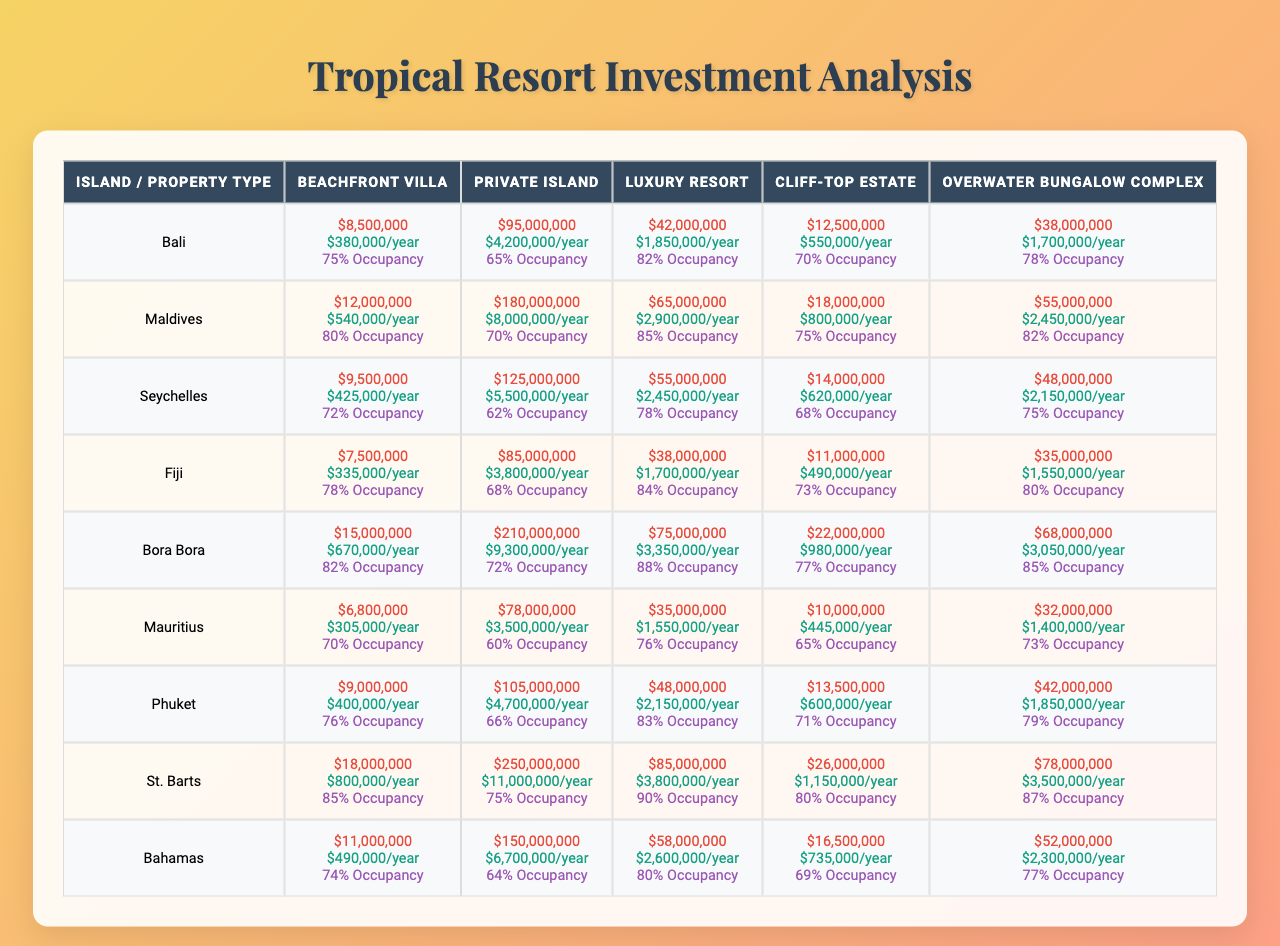What is the acquisition cost of a Beachfront Villa in Bora Bora? According to the table, the acquisition cost for a Beachfront Villa in Bora Bora is $15,000,000.
Answer: $15,000,000 Which island has the highest acquisition cost for a Private Island? By examining the table, the Maldives has the highest acquisition cost for a Private Island at $180,000,000.
Answer: Maldives What is the average occupancy rate for Luxury Resorts across all islands? Summing the average occupancy rates for Luxury Resorts (0.82 + 0.85 + 0.78 + 0.84 + 0.88 + 0.76 + 0.83 + 0.90 + 0.80) gives 7.34, and dividing by the number of islands (9) results in an average of 0.8156, or approximately 81.56%.
Answer: 81.56% Is the yearly maintenance cost for a Cliff-top Estate in Bali higher than $1,000,000? The yearly maintenance cost for a Cliff-top Estate in Bali is $550,000, which is less than $1,000,000.
Answer: No What is the total acquisition cost for Luxury Resorts from all the islands? The acquisition costs for Luxury Resorts from the islands are ($42,000,000 + $65,000,000 + $55,000,000 + $38,000,000 + $75,000,000 + $35,000,000 + $48,000,000 + $85,000,000 + $58,000,000), totaling $488,000,000.
Answer: $488,000,000 Which island has the lowest yearly maintenance cost for an Overwater Bungalow Complex? Referring to the table, Mauritius has the lowest yearly maintenance cost for an Overwater Bungalow Complex at $1,400,000.
Answer: Mauritius If I were to acquire a Luxury Resort in both Seychelles and Maldives, what would be the total acquisition cost? The acquisition costs for Luxury Resorts in Seychelles and Maldives are $55,000,000 and $65,000,000 respectively. Adding these together ($55,000,000 + $65,000,000) results in a total acquisition cost of $120,000,000.
Answer: $120,000,000 Is the average occupancy rate for St. Barts’ beachfront villas lower than 75%? The average occupancy rate for St. Barts’ Beachfront Villas is 85%, which is higher than 75%.
Answer: No How does the yearly maintenance cost for a Private Island in Fiji compare to that in Maui? The yearly maintenance cost for a Private Island in Fiji is $8,000,000, while in Maui, it is $8,000,000 as well, so they are the same.
Answer: They are the same What is the difference in acquisition cost between the most expensive and least expensive Cliff-top Estate? The most expensive Cliff-top Estate is in Bora Bora at $22,000,000 and the least expensive is in Bali at $11,000,000. The difference is $22,000,000 - $11,000,000 = $11,000,000.
Answer: $11,000,000 